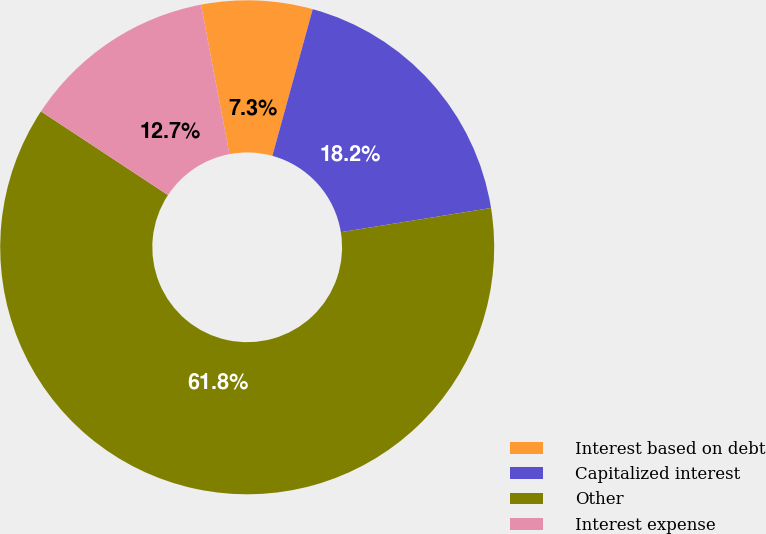<chart> <loc_0><loc_0><loc_500><loc_500><pie_chart><fcel>Interest based on debt<fcel>Capitalized interest<fcel>Other<fcel>Interest expense<nl><fcel>7.27%<fcel>18.18%<fcel>61.82%<fcel>12.73%<nl></chart> 